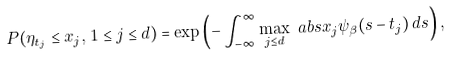Convert formula to latex. <formula><loc_0><loc_0><loc_500><loc_500>P ( \eta _ { t _ { j } } \leq x _ { j } , \, 1 \leq j \leq d ) & = \exp \left ( - \int _ { - \infty } ^ { \infty } \max _ { j \leq d } \ a b s { x _ { j } } \psi _ { \beta } ( s - t _ { j } ) \, d s \right ) ,</formula> 